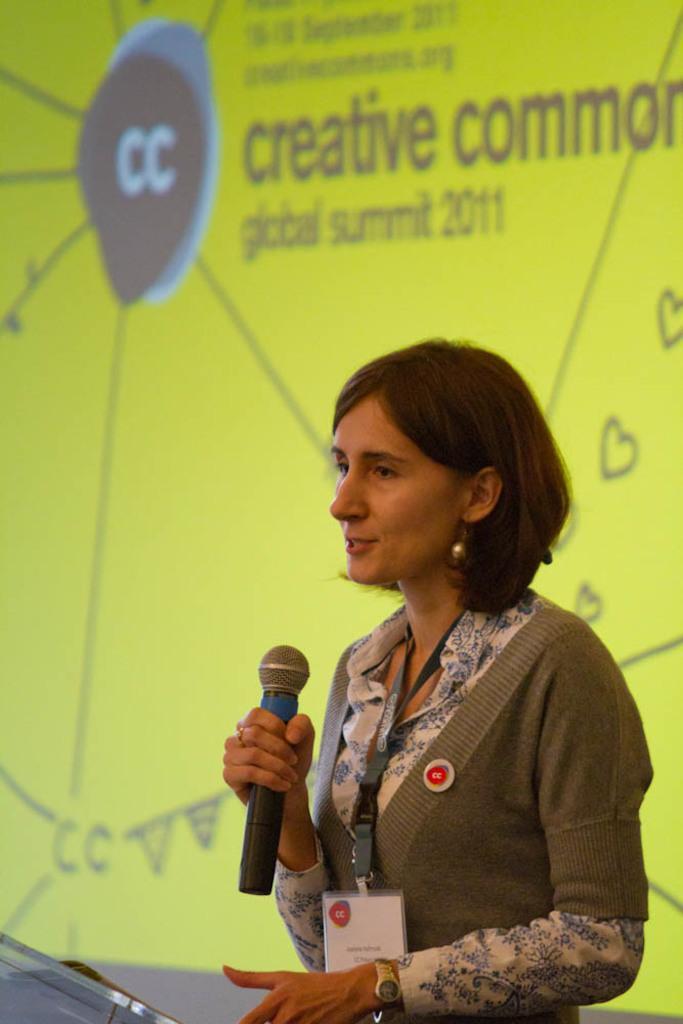Can you describe this image briefly? In this image I can see the person wearing the white, blue and ash color dress. The person standing in-front of the podium and holding the mic. In the background I can see the yellow color screen. 